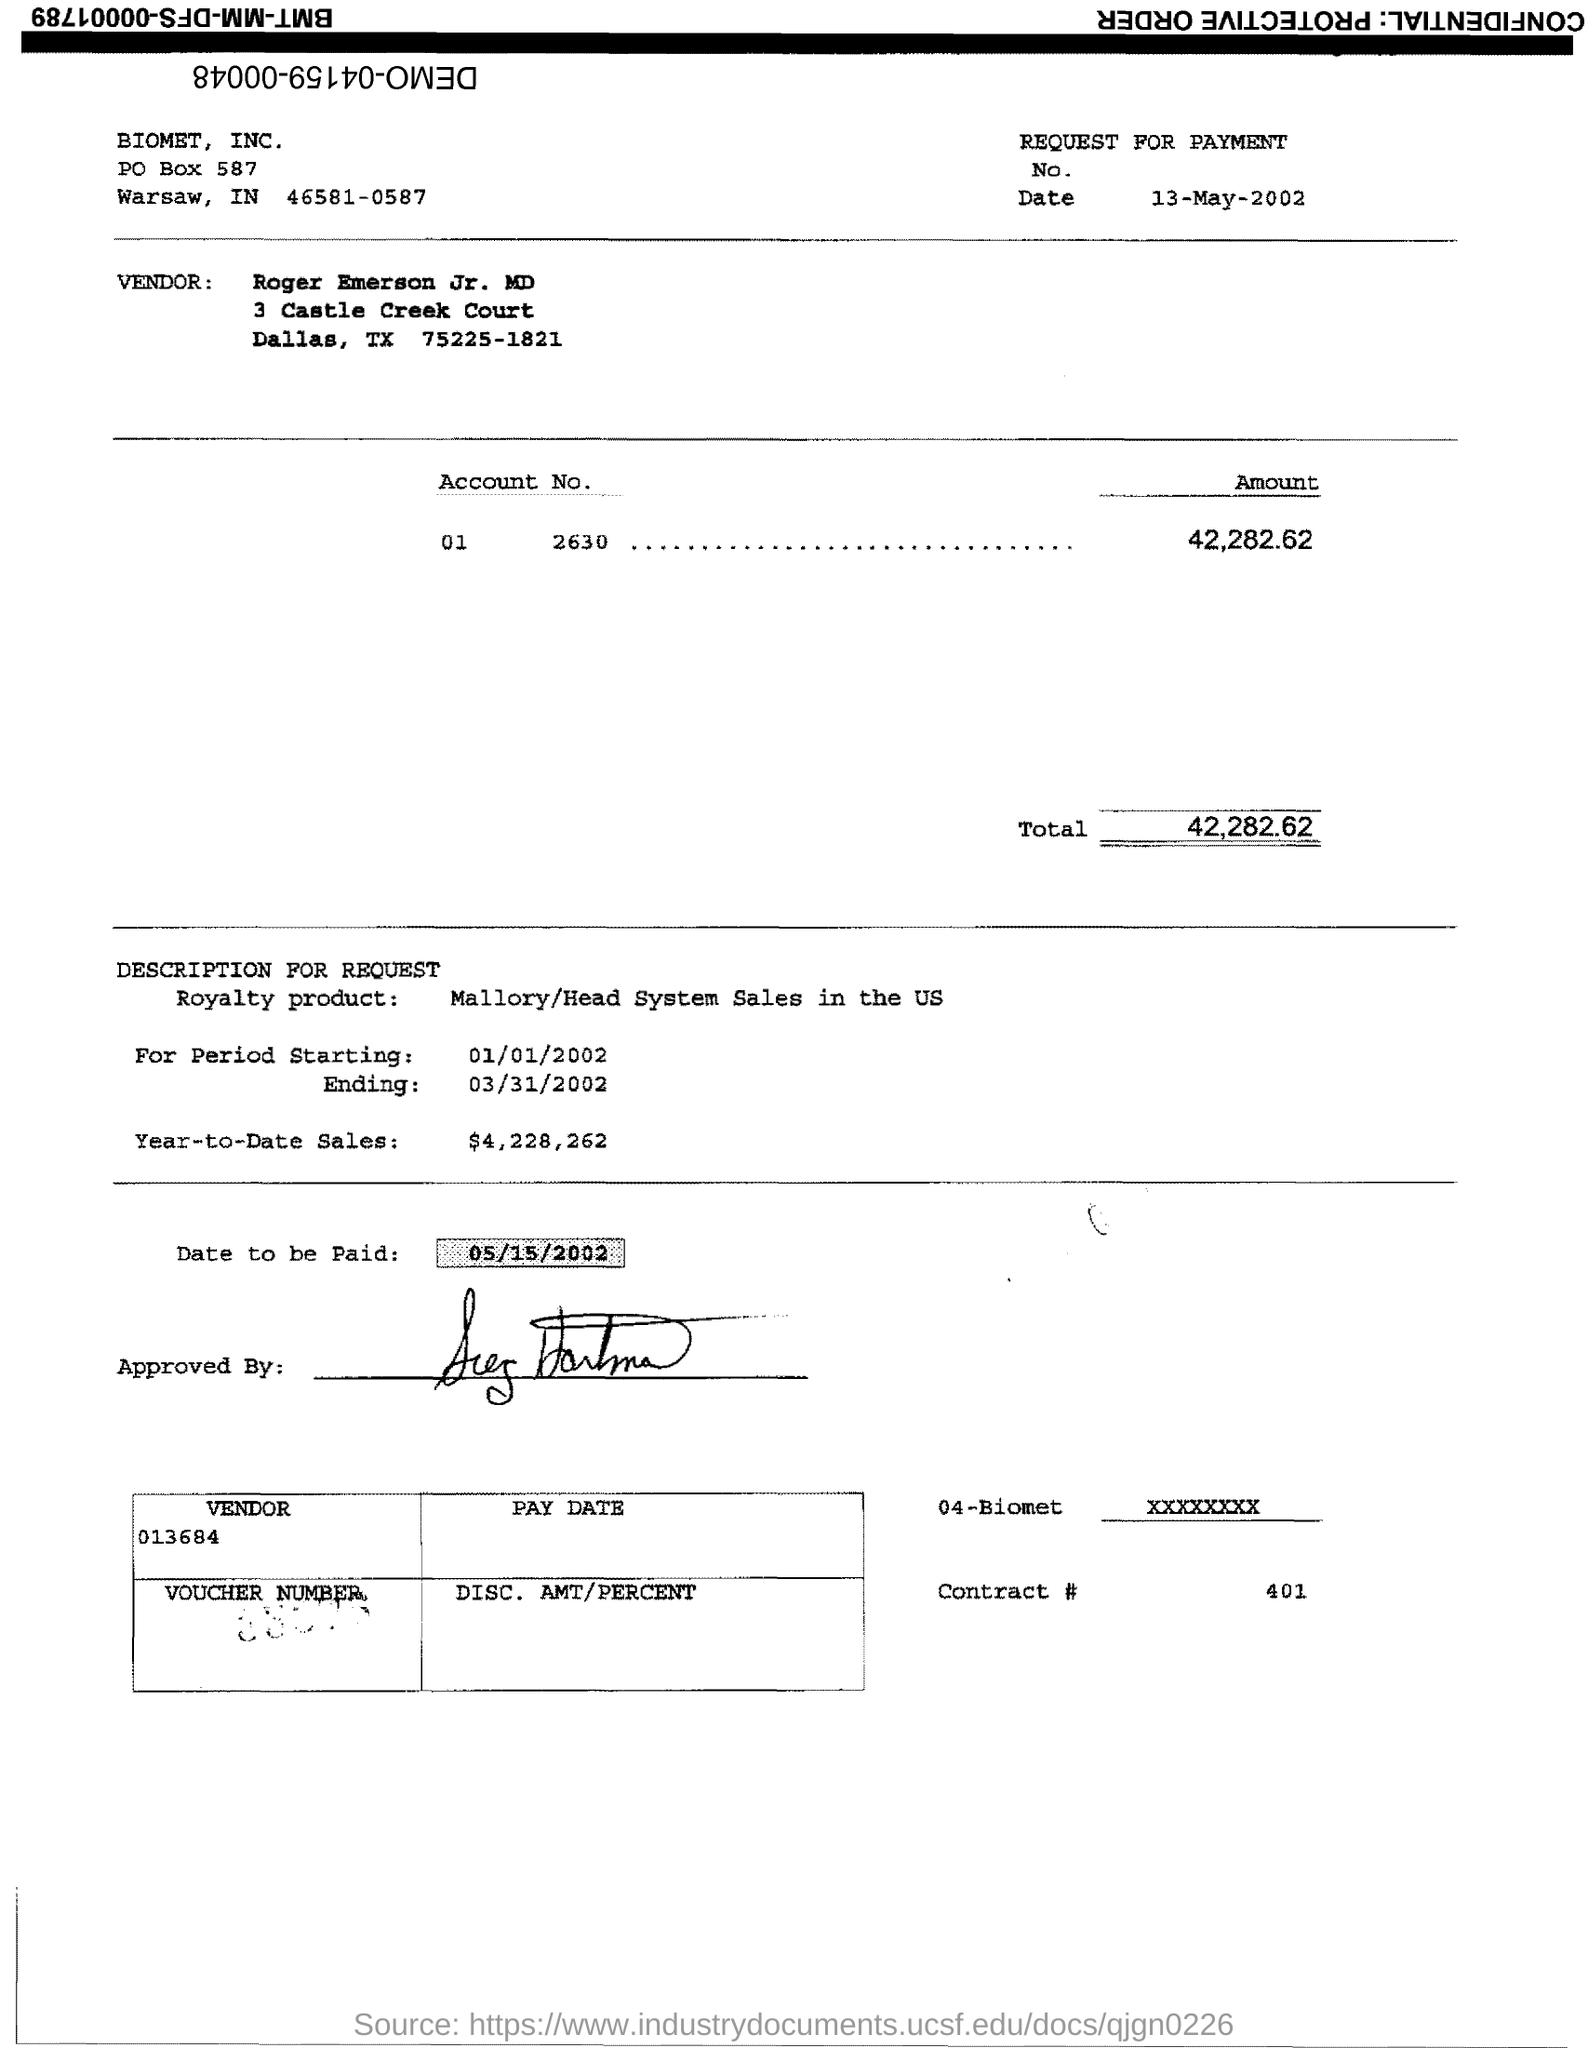What is the Total?
Your answer should be compact. 42,282.62. What is the Contract # Number?
Provide a succinct answer. 401. What is the PO Box Number mentioned in the document?
Ensure brevity in your answer.  587. 